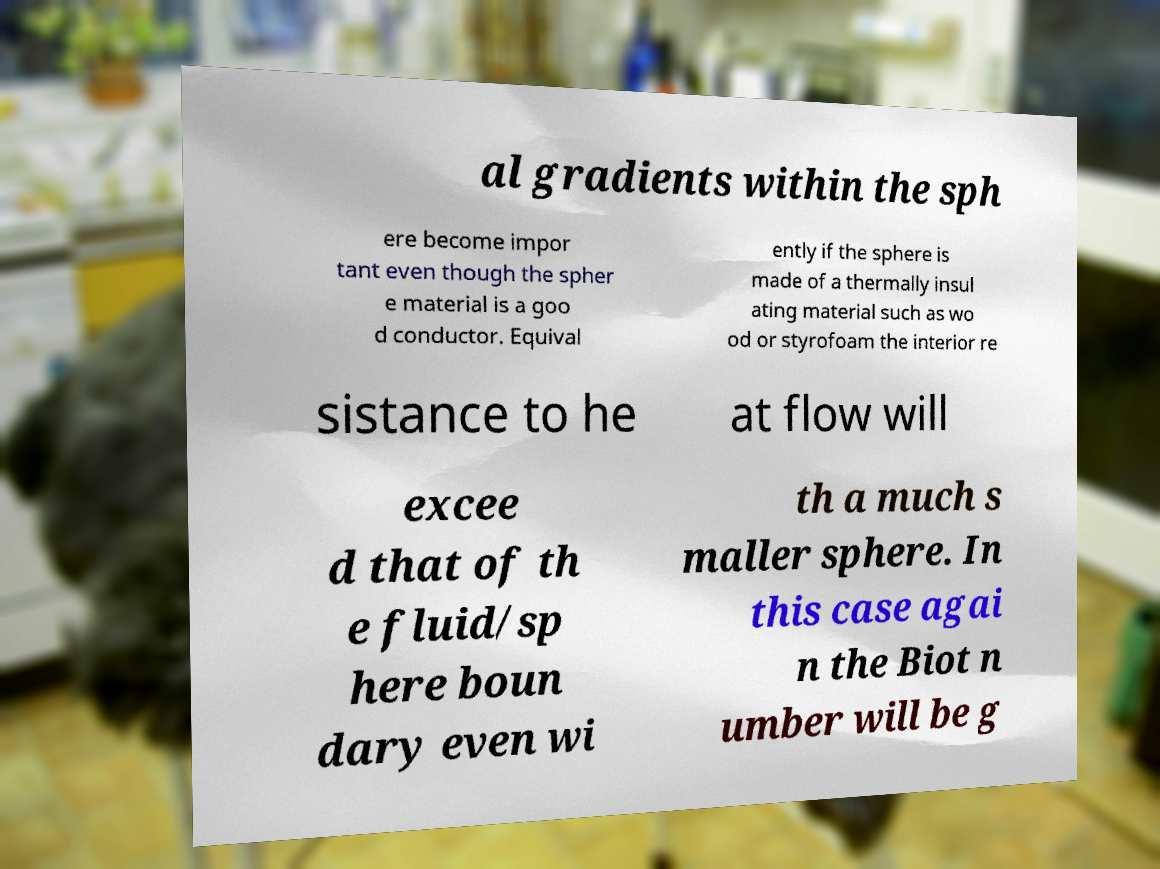I need the written content from this picture converted into text. Can you do that? al gradients within the sph ere become impor tant even though the spher e material is a goo d conductor. Equival ently if the sphere is made of a thermally insul ating material such as wo od or styrofoam the interior re sistance to he at flow will excee d that of th e fluid/sp here boun dary even wi th a much s maller sphere. In this case agai n the Biot n umber will be g 